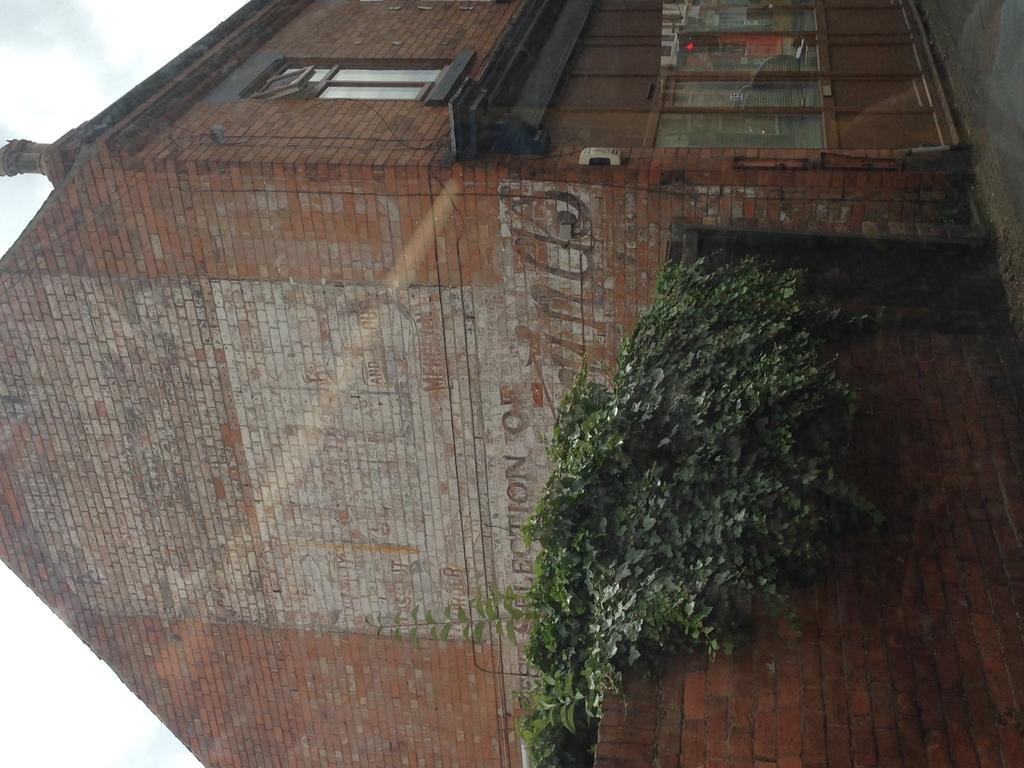How would you summarize this image in a sentence or two? In this image we can see the building with windows and at the side, we can see the wall and plants. And there is the sky in the background. 